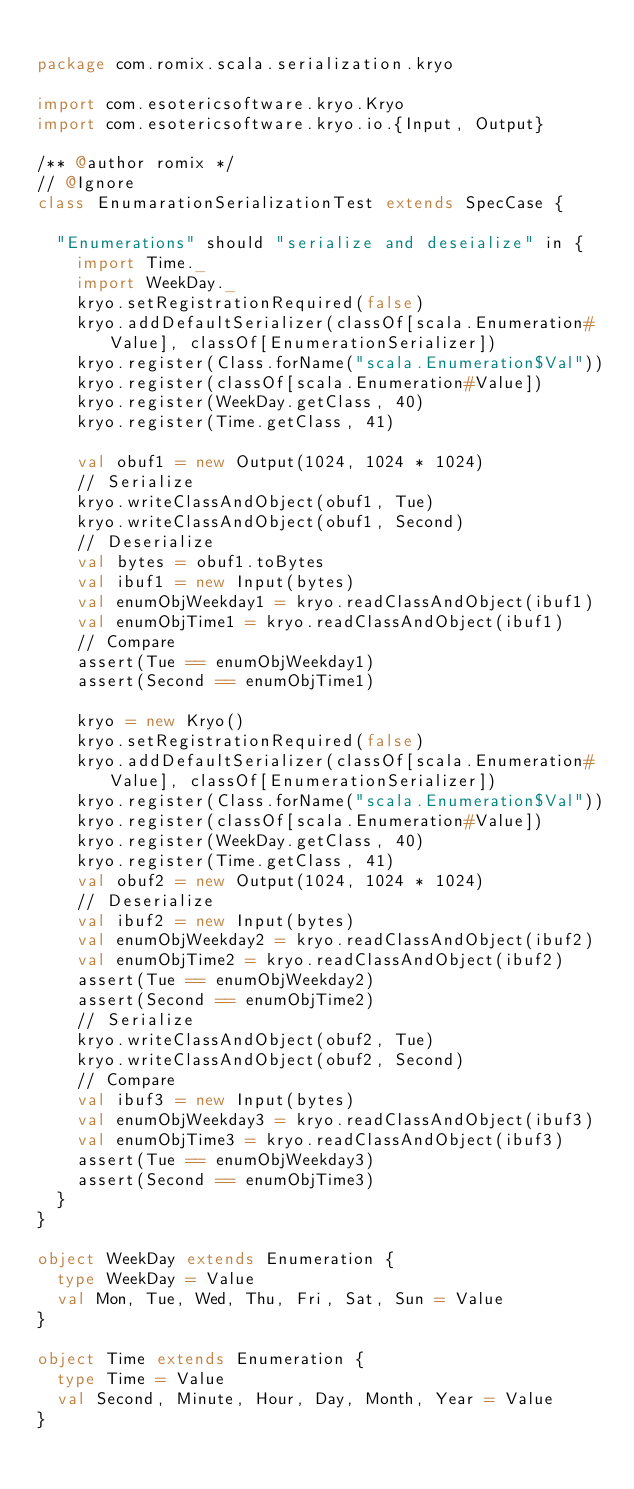<code> <loc_0><loc_0><loc_500><loc_500><_Scala_>
package com.romix.scala.serialization.kryo

import com.esotericsoftware.kryo.Kryo
import com.esotericsoftware.kryo.io.{Input, Output}

/** @author romix */
// @Ignore
class EnumarationSerializationTest extends SpecCase {

  "Enumerations" should "serialize and deseialize" in {
    import Time._
    import WeekDay._
    kryo.setRegistrationRequired(false)
    kryo.addDefaultSerializer(classOf[scala.Enumeration#Value], classOf[EnumerationSerializer])
    kryo.register(Class.forName("scala.Enumeration$Val"))
    kryo.register(classOf[scala.Enumeration#Value])
    kryo.register(WeekDay.getClass, 40)
    kryo.register(Time.getClass, 41)

    val obuf1 = new Output(1024, 1024 * 1024)
    // Serialize
    kryo.writeClassAndObject(obuf1, Tue)
    kryo.writeClassAndObject(obuf1, Second)
    // Deserialize
    val bytes = obuf1.toBytes
    val ibuf1 = new Input(bytes)
    val enumObjWeekday1 = kryo.readClassAndObject(ibuf1)
    val enumObjTime1 = kryo.readClassAndObject(ibuf1)
    // Compare
    assert(Tue == enumObjWeekday1)
    assert(Second == enumObjTime1)

    kryo = new Kryo()
    kryo.setRegistrationRequired(false)
    kryo.addDefaultSerializer(classOf[scala.Enumeration#Value], classOf[EnumerationSerializer])
    kryo.register(Class.forName("scala.Enumeration$Val"))
    kryo.register(classOf[scala.Enumeration#Value])
    kryo.register(WeekDay.getClass, 40)
    kryo.register(Time.getClass, 41)
    val obuf2 = new Output(1024, 1024 * 1024)
    // Deserialize
    val ibuf2 = new Input(bytes)
    val enumObjWeekday2 = kryo.readClassAndObject(ibuf2)
    val enumObjTime2 = kryo.readClassAndObject(ibuf2)
    assert(Tue == enumObjWeekday2)
    assert(Second == enumObjTime2)
    // Serialize
    kryo.writeClassAndObject(obuf2, Tue)
    kryo.writeClassAndObject(obuf2, Second)
    // Compare
    val ibuf3 = new Input(bytes)
    val enumObjWeekday3 = kryo.readClassAndObject(ibuf3)
    val enumObjTime3 = kryo.readClassAndObject(ibuf3)
    assert(Tue == enumObjWeekday3)
    assert(Second == enumObjTime3)
  }
}

object WeekDay extends Enumeration {
  type WeekDay = Value
  val Mon, Tue, Wed, Thu, Fri, Sat, Sun = Value
}

object Time extends Enumeration {
  type Time = Value
  val Second, Minute, Hour, Day, Month, Year = Value
}
</code> 